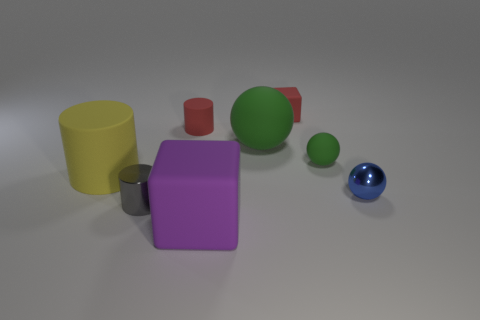Add 2 small objects. How many objects exist? 10 Subtract all blocks. How many objects are left? 6 Add 4 big red rubber cubes. How many big red rubber cubes exist? 4 Subtract 0 green cubes. How many objects are left? 8 Subtract all small gray matte balls. Subtract all big purple cubes. How many objects are left? 7 Add 5 tiny red things. How many tiny red things are left? 7 